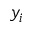Convert formula to latex. <formula><loc_0><loc_0><loc_500><loc_500>y _ { i }</formula> 